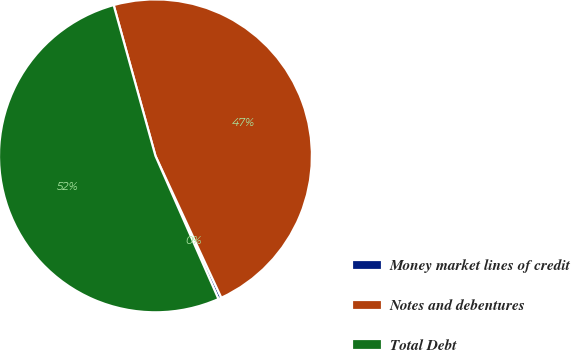Convert chart to OTSL. <chart><loc_0><loc_0><loc_500><loc_500><pie_chart><fcel>Money market lines of credit<fcel>Notes and debentures<fcel>Total Debt<nl><fcel>0.32%<fcel>47.38%<fcel>52.29%<nl></chart> 